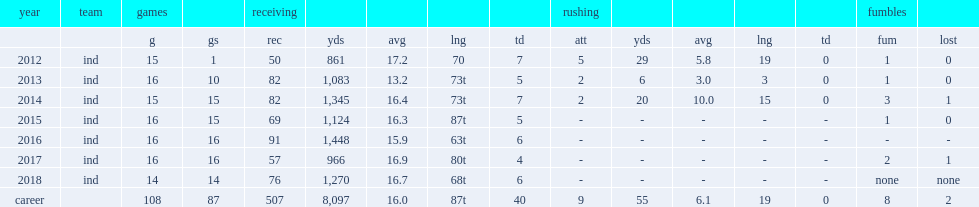How many receptions did t. y. hilton get in 2018? 76.0. 